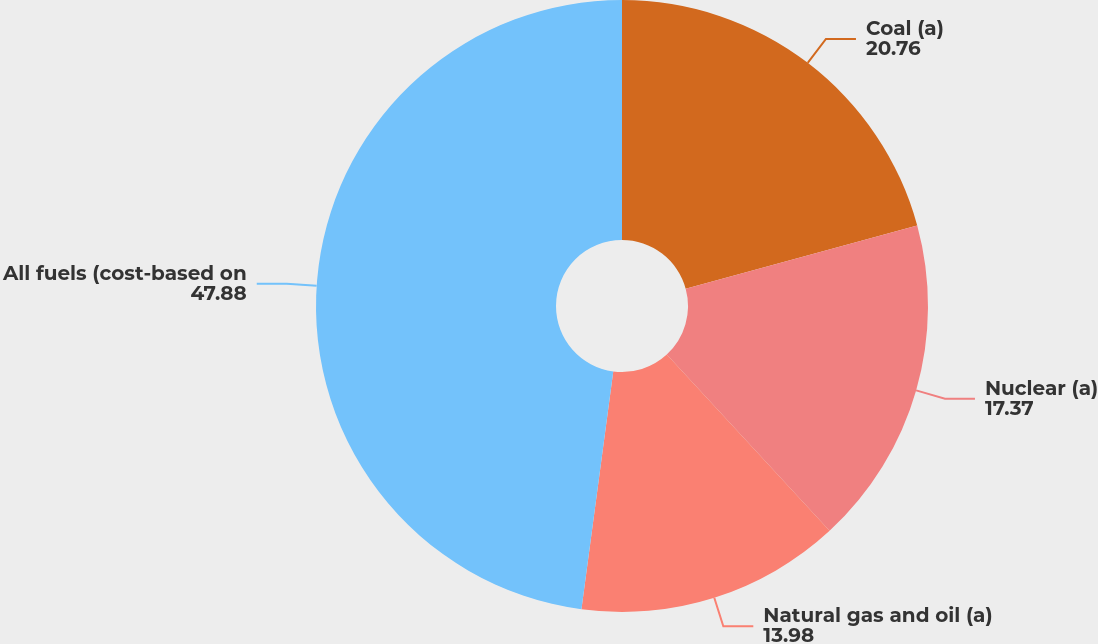Convert chart. <chart><loc_0><loc_0><loc_500><loc_500><pie_chart><fcel>Coal (a)<fcel>Nuclear (a)<fcel>Natural gas and oil (a)<fcel>All fuels (cost-based on<nl><fcel>20.76%<fcel>17.37%<fcel>13.98%<fcel>47.88%<nl></chart> 